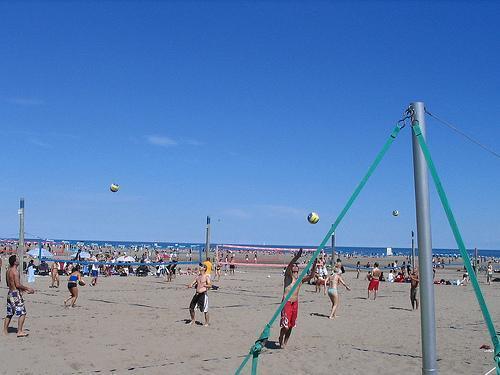How many balls are there?
Give a very brief answer. 3. 